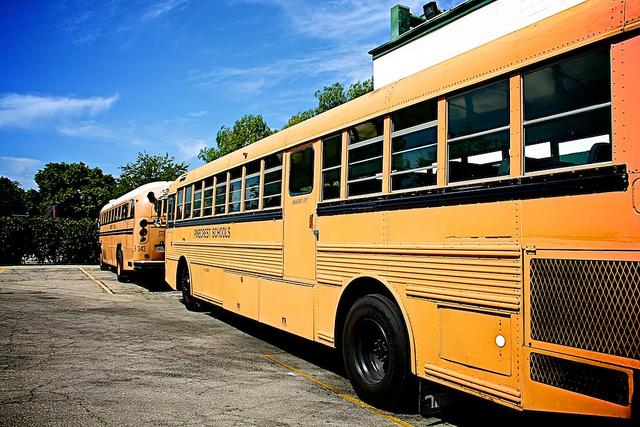Are there passengers in the last bus?
Quick response, please. No. How many buses are there?
Quick response, please. 2. What is the purpose of this vehicle?
Give a very brief answer. School bus. 